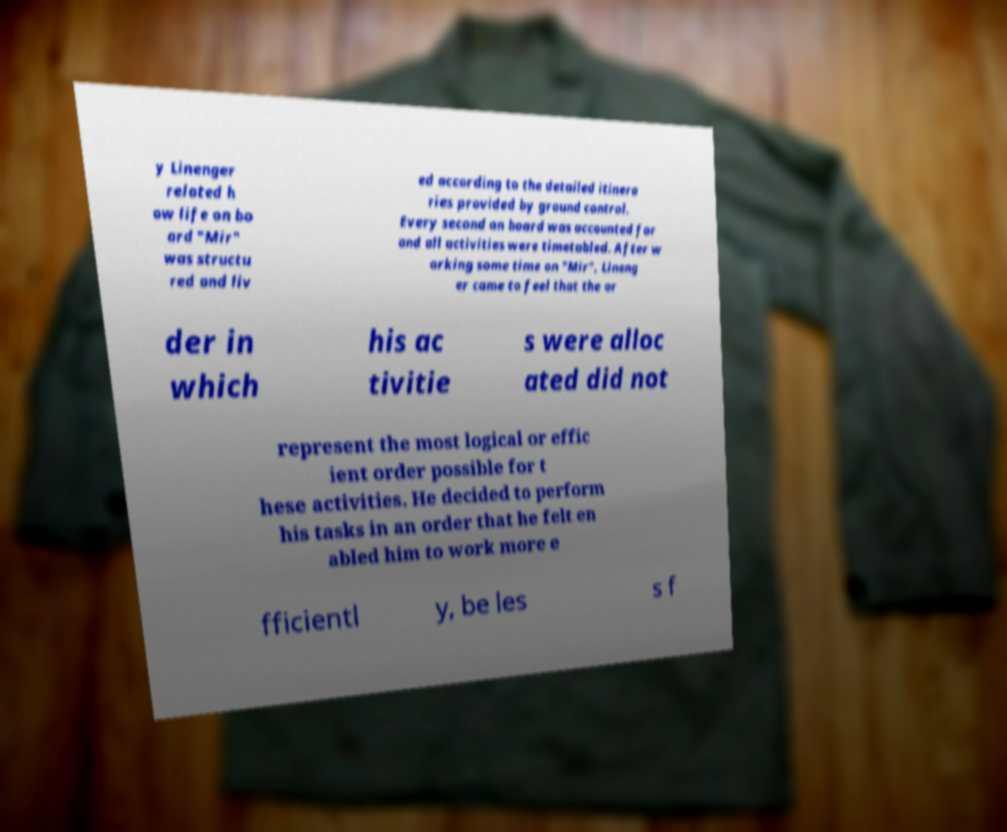There's text embedded in this image that I need extracted. Can you transcribe it verbatim? y Linenger related h ow life on bo ard "Mir" was structu red and liv ed according to the detailed itinera ries provided by ground control. Every second on board was accounted for and all activities were timetabled. After w orking some time on "Mir", Lineng er came to feel that the or der in which his ac tivitie s were alloc ated did not represent the most logical or effic ient order possible for t hese activities. He decided to perform his tasks in an order that he felt en abled him to work more e fficientl y, be les s f 